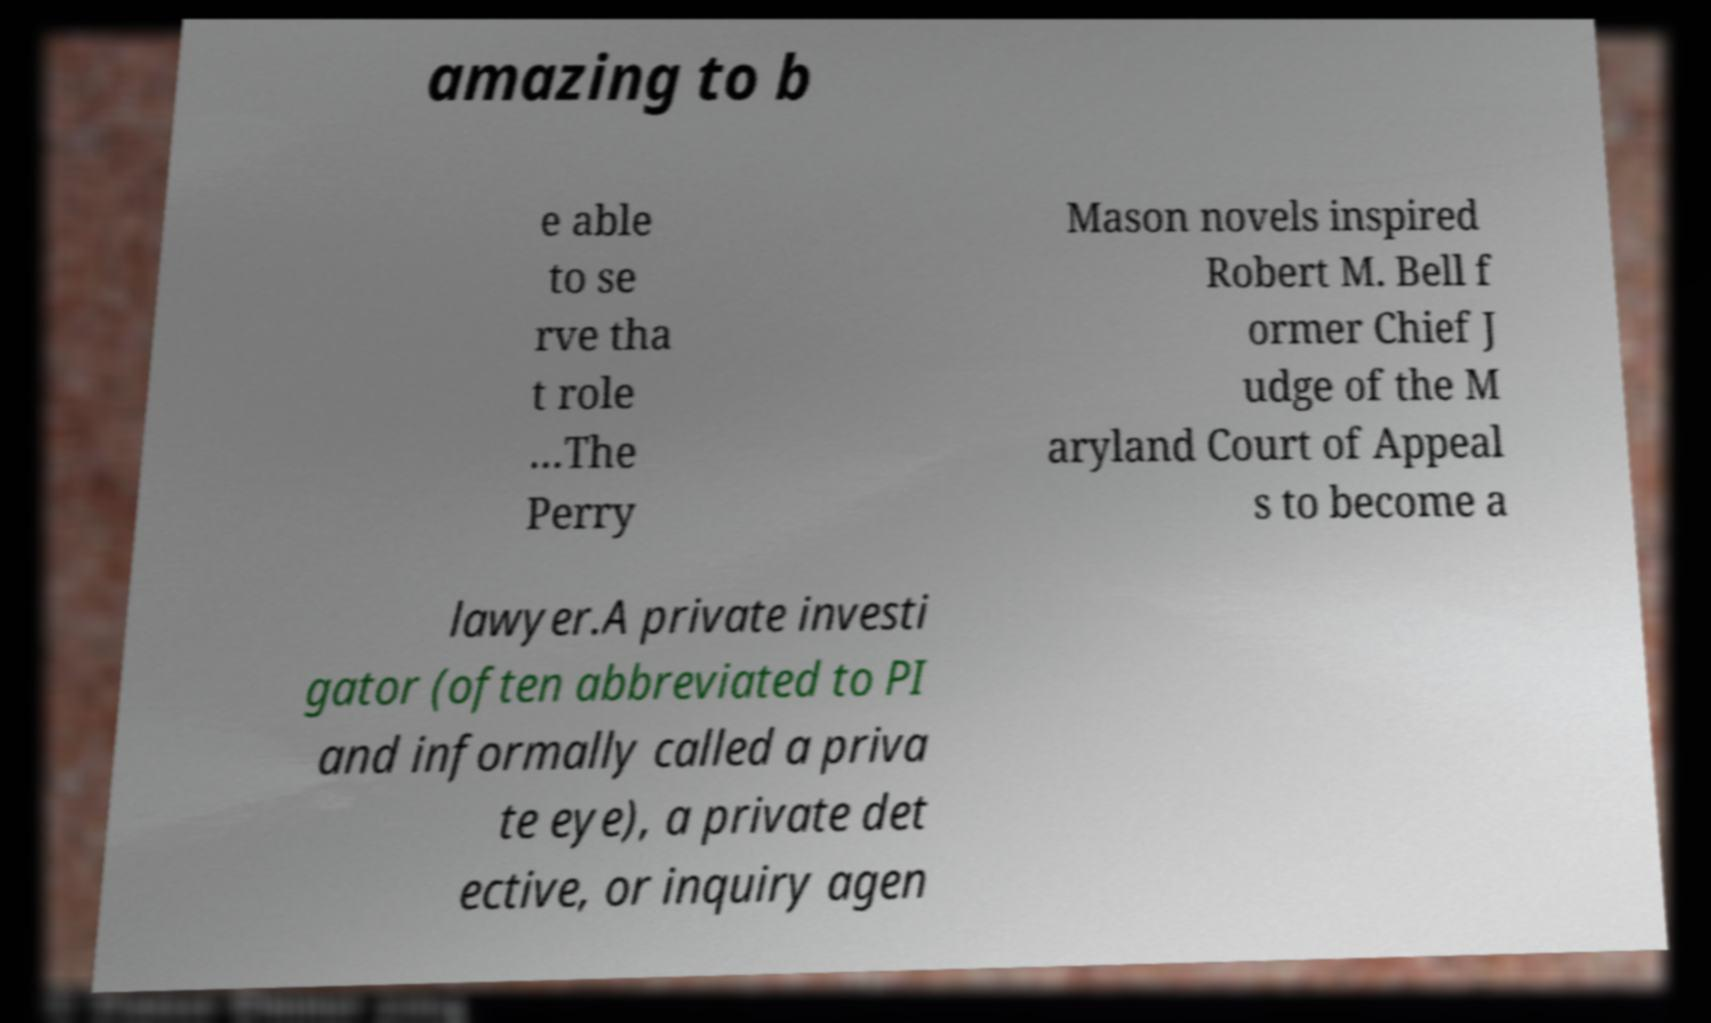Can you read and provide the text displayed in the image?This photo seems to have some interesting text. Can you extract and type it out for me? amazing to b e able to se rve tha t role …The Perry Mason novels inspired Robert M. Bell f ormer Chief J udge of the M aryland Court of Appeal s to become a lawyer.A private investi gator (often abbreviated to PI and informally called a priva te eye), a private det ective, or inquiry agen 